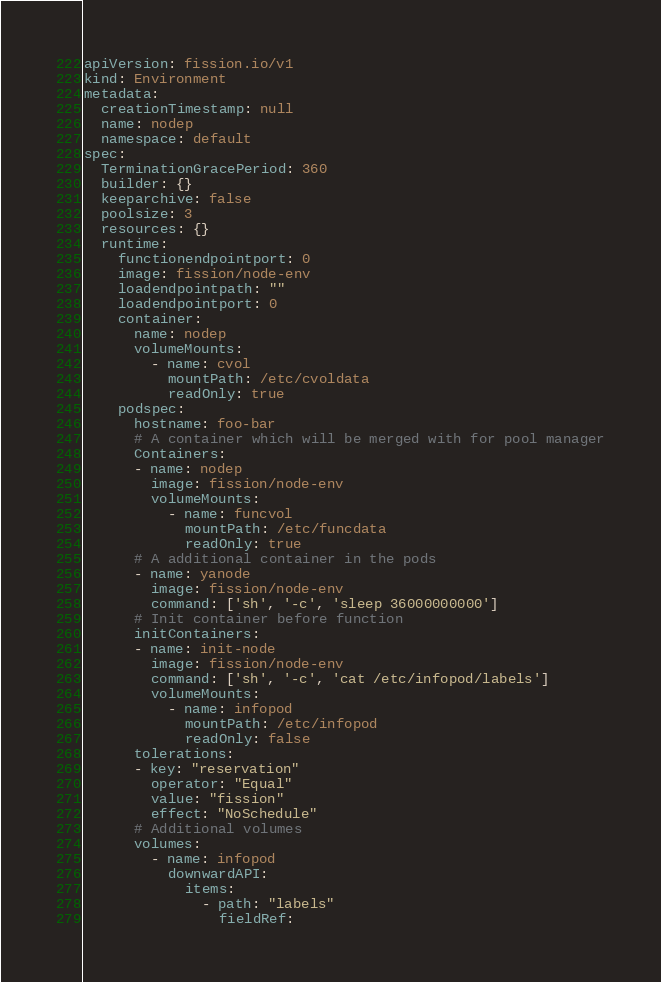<code> <loc_0><loc_0><loc_500><loc_500><_YAML_>apiVersion: fission.io/v1
kind: Environment
metadata:
  creationTimestamp: null
  name: nodep
  namespace: default
spec:
  TerminationGracePeriod: 360
  builder: {}
  keeparchive: false
  poolsize: 3
  resources: {}
  runtime:
    functionendpointport: 0
    image: fission/node-env
    loadendpointpath: ""
    loadendpointport: 0
    container:
      name: nodep
      volumeMounts:
        - name: cvol
          mountPath: /etc/cvoldata
          readOnly: true
    podspec:
      hostname: foo-bar
      # A container which will be merged with for pool manager
      Containers:
      - name: nodep
        image: fission/node-env
        volumeMounts:
          - name: funcvol
            mountPath: /etc/funcdata
            readOnly: true
      # A additional container in the pods
      - name: yanode
        image: fission/node-env
        command: ['sh', '-c', 'sleep 36000000000']
      # Init container before function
      initContainers:
      - name: init-node
        image: fission/node-env 
        command: ['sh', '-c', 'cat /etc/infopod/labels']
        volumeMounts:
          - name: infopod
            mountPath: /etc/infopod
            readOnly: false
      tolerations:
      - key: "reservation"
        operator: "Equal"
        value: "fission"
        effect: "NoSchedule"      
      # Additional volumes
      volumes:
        - name: infopod
          downwardAPI:
            items:
              - path: "labels"
                fieldRef:</code> 